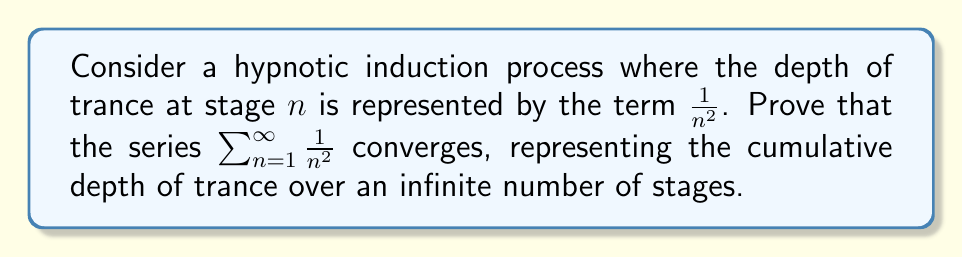Can you answer this question? To prove the convergence of this series, we'll use the comparison test with a p-series.

1) First, recall that for a p-series $\sum_{n=1}^{\infty} \frac{1}{n^p}$:
   - If $p > 1$, the series converges
   - If $p \leq 1$, the series diverges

2) In our case, the series is $\sum_{n=1}^{\infty} \frac{1}{n^2}$, which is a p-series with $p = 2$.

3) Since $2 > 1$, we can conclude that this series converges.

4) For a more rigorous proof, we can use the integral test:

   Let $f(x) = \frac{1}{x^2}$. This function is positive, continuous, and decreasing on $[1,\infty)$.

   The integral test states that if $\int_1^{\infty} f(x)dx$ converges, then $\sum_{n=1}^{\infty} f(n)$ also converges.

5) Let's evaluate the integral:

   $$\int_1^{\infty} \frac{1}{x^2}dx = \lim_{b\to\infty} \int_1^b \frac{1}{x^2}dx = \lim_{b\to\infty} [-\frac{1}{x}]_1^b = \lim_{b\to\infty} (-\frac{1}{b} + 1) = 1$$

6) Since this integral converges to 1, the series $\sum_{n=1}^{\infty} \frac{1}{n^2}$ must also converge.

7) In fact, it's known that this series converges to $\frac{\pi^2}{6}$, though proving this exact value is beyond the scope of this question.
Answer: The series $\sum_{n=1}^{\infty} \frac{1}{n^2}$ converges. This can be proven using either the comparison test with p-series or the integral test. 